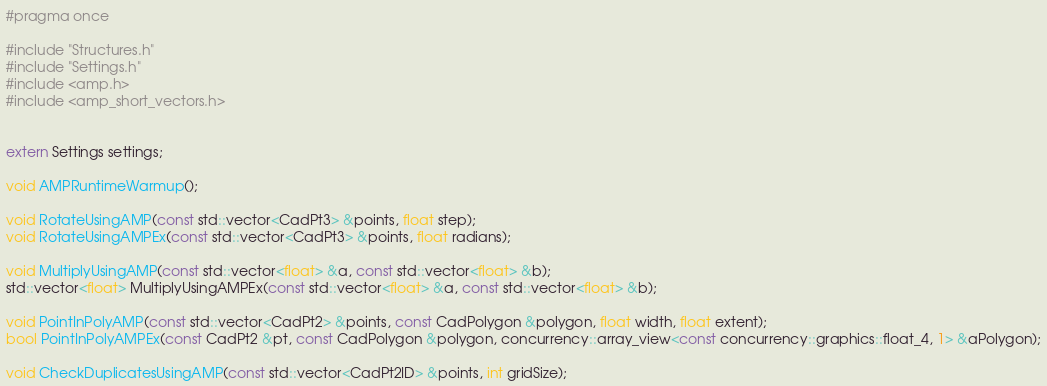Convert code to text. <code><loc_0><loc_0><loc_500><loc_500><_C_>#pragma once

#include "Structures.h"
#include "Settings.h"
#include <amp.h>
#include <amp_short_vectors.h>


extern Settings settings;

void AMPRuntimeWarmup();

void RotateUsingAMP(const std::vector<CadPt3> &points, float step);
void RotateUsingAMPEx(const std::vector<CadPt3> &points, float radians);

void MultiplyUsingAMP(const std::vector<float> &a, const std::vector<float> &b); 
std::vector<float> MultiplyUsingAMPEx(const std::vector<float> &a, const std::vector<float> &b);

void PointInPolyAMP(const std::vector<CadPt2> &points, const CadPolygon &polygon, float width, float extent);
bool PointInPolyAMPEx(const CadPt2 &pt, const CadPolygon &polygon, concurrency::array_view<const concurrency::graphics::float_4, 1> &aPolygon);

void CheckDuplicatesUsingAMP(const std::vector<CadPt2ID> &points, int gridSize);

</code> 